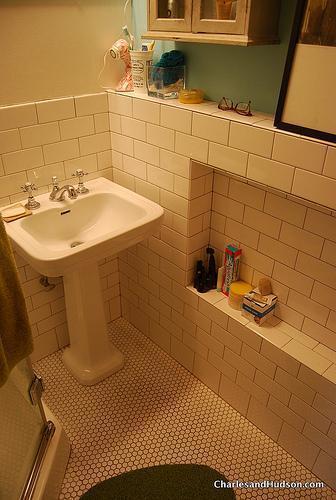How many sinks are in the photo?
Give a very brief answer. 1. How many eyeglasses in the bathroom?
Give a very brief answer. 1. 